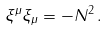<formula> <loc_0><loc_0><loc_500><loc_500>\xi ^ { \mu } \xi _ { \mu } = - N ^ { 2 } \, .</formula> 